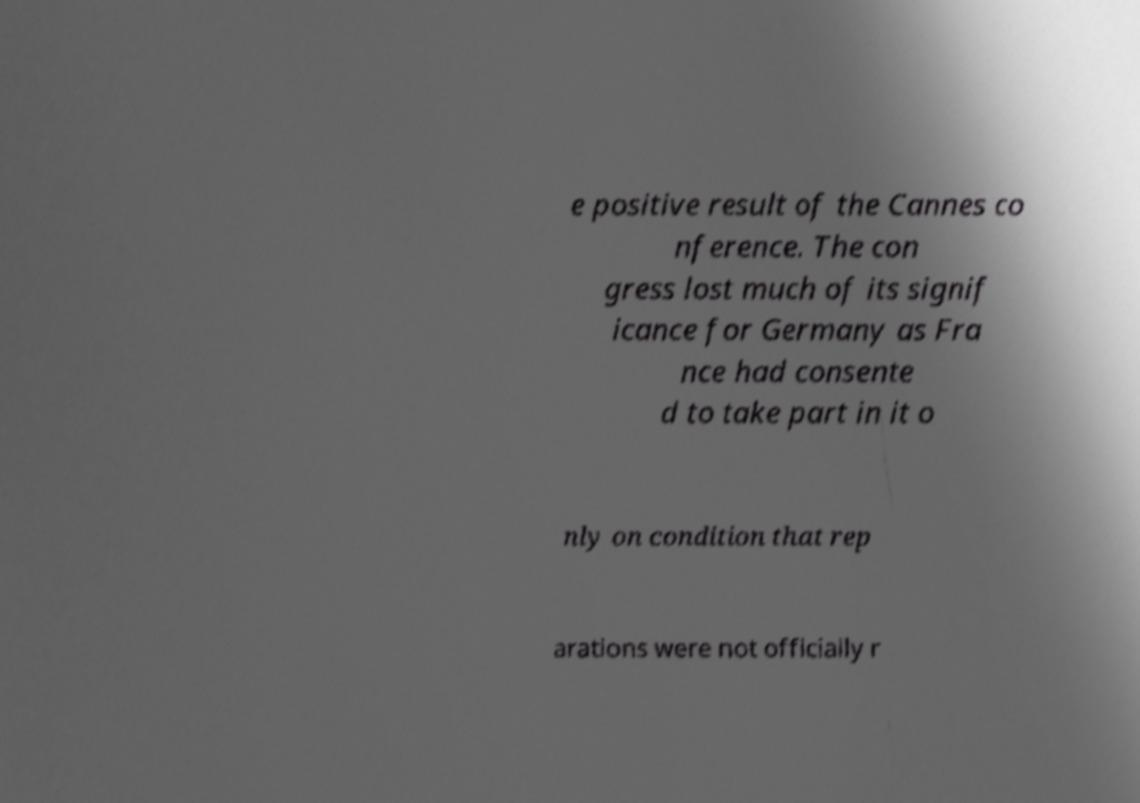I need the written content from this picture converted into text. Can you do that? e positive result of the Cannes co nference. The con gress lost much of its signif icance for Germany as Fra nce had consente d to take part in it o nly on condition that rep arations were not officially r 